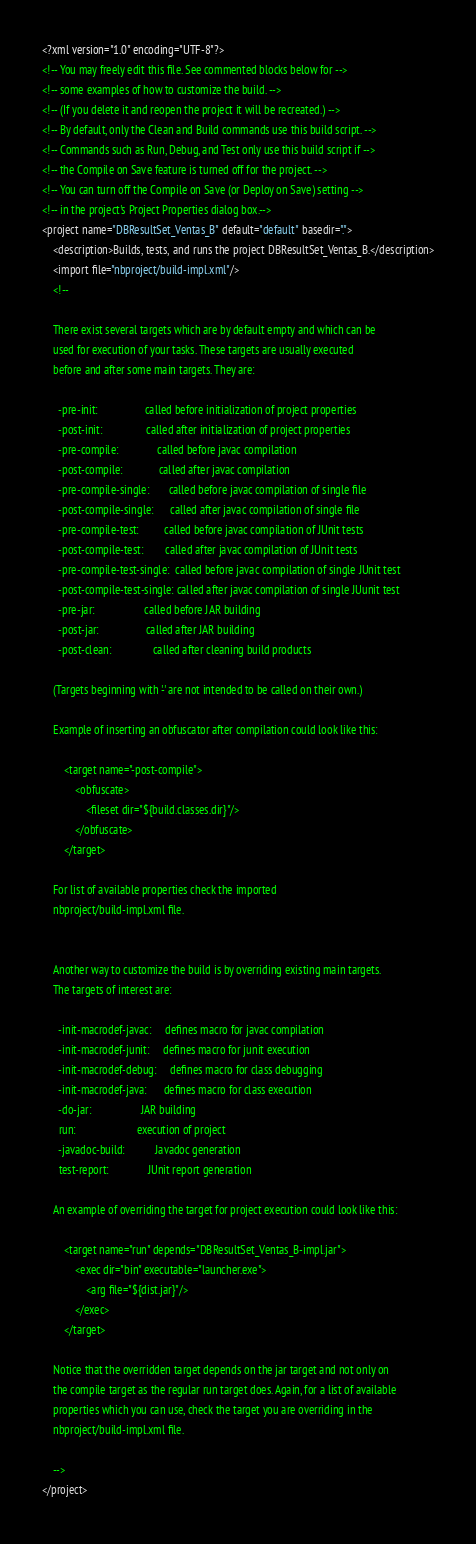Convert code to text. <code><loc_0><loc_0><loc_500><loc_500><_XML_><?xml version="1.0" encoding="UTF-8"?>
<!-- You may freely edit this file. See commented blocks below for -->
<!-- some examples of how to customize the build. -->
<!-- (If you delete it and reopen the project it will be recreated.) -->
<!-- By default, only the Clean and Build commands use this build script. -->
<!-- Commands such as Run, Debug, and Test only use this build script if -->
<!-- the Compile on Save feature is turned off for the project. -->
<!-- You can turn off the Compile on Save (or Deploy on Save) setting -->
<!-- in the project's Project Properties dialog box.-->
<project name="DBResultSet_Ventas_B" default="default" basedir=".">
    <description>Builds, tests, and runs the project DBResultSet_Ventas_B.</description>
    <import file="nbproject/build-impl.xml"/>
    <!--

    There exist several targets which are by default empty and which can be 
    used for execution of your tasks. These targets are usually executed 
    before and after some main targets. They are: 

      -pre-init:                 called before initialization of project properties
      -post-init:                called after initialization of project properties
      -pre-compile:              called before javac compilation
      -post-compile:             called after javac compilation
      -pre-compile-single:       called before javac compilation of single file
      -post-compile-single:      called after javac compilation of single file
      -pre-compile-test:         called before javac compilation of JUnit tests
      -post-compile-test:        called after javac compilation of JUnit tests
      -pre-compile-test-single:  called before javac compilation of single JUnit test
      -post-compile-test-single: called after javac compilation of single JUunit test
      -pre-jar:                  called before JAR building
      -post-jar:                 called after JAR building
      -post-clean:               called after cleaning build products

    (Targets beginning with '-' are not intended to be called on their own.)

    Example of inserting an obfuscator after compilation could look like this:

        <target name="-post-compile">
            <obfuscate>
                <fileset dir="${build.classes.dir}"/>
            </obfuscate>
        </target>

    For list of available properties check the imported 
    nbproject/build-impl.xml file. 


    Another way to customize the build is by overriding existing main targets.
    The targets of interest are: 

      -init-macrodef-javac:     defines macro for javac compilation
      -init-macrodef-junit:     defines macro for junit execution
      -init-macrodef-debug:     defines macro for class debugging
      -init-macrodef-java:      defines macro for class execution
      -do-jar:                  JAR building
      run:                      execution of project 
      -javadoc-build:           Javadoc generation
      test-report:              JUnit report generation

    An example of overriding the target for project execution could look like this:

        <target name="run" depends="DBResultSet_Ventas_B-impl.jar">
            <exec dir="bin" executable="launcher.exe">
                <arg file="${dist.jar}"/>
            </exec>
        </target>

    Notice that the overridden target depends on the jar target and not only on 
    the compile target as the regular run target does. Again, for a list of available 
    properties which you can use, check the target you are overriding in the
    nbproject/build-impl.xml file. 

    -->
</project>
</code> 